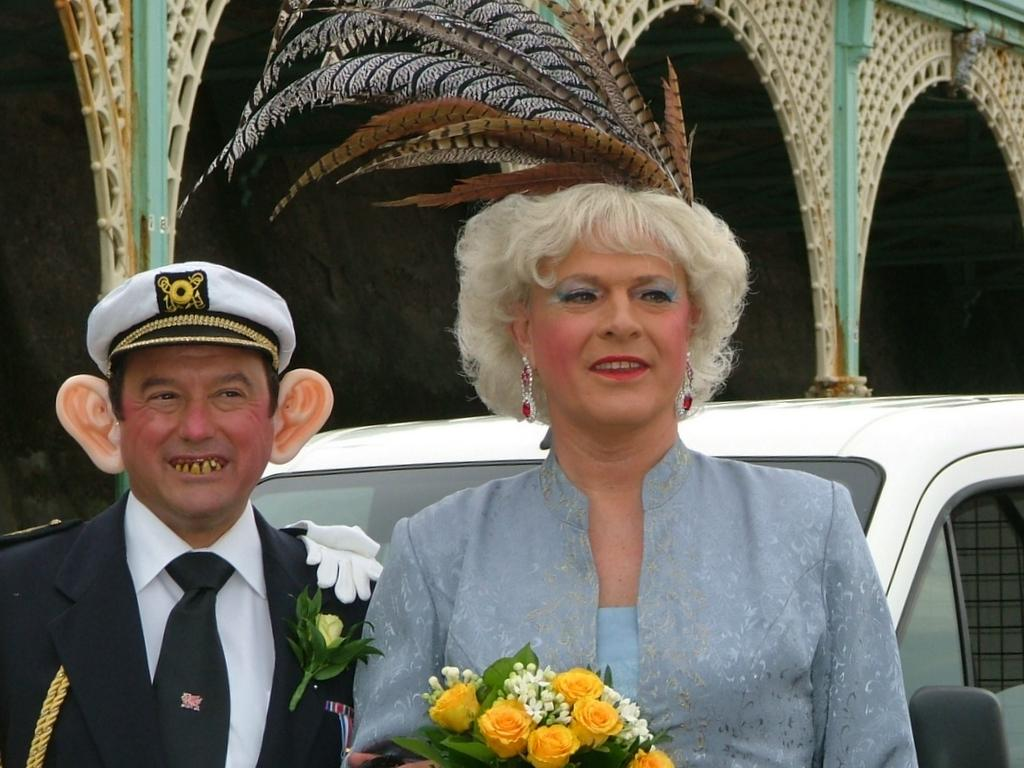Who is present in the image? There is a woman in the image. What is the woman holding? The woman is holding a flower bouquet. What else can be seen in the image? There is a car and pillars visible in the image. What type of fowl can be seen sitting on the car in the image? There is no fowl present on the car in the image. Is there a crook visible in the image? There is no crook present in the image. 